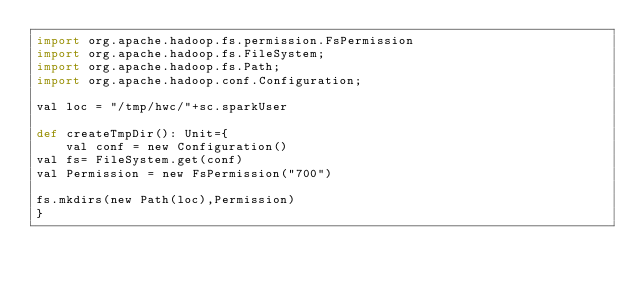Convert code to text. <code><loc_0><loc_0><loc_500><loc_500><_Python_>import org.apache.hadoop.fs.permission.FsPermission
import org.apache.hadoop.fs.FileSystem;
import org.apache.hadoop.fs.Path;
import org.apache.hadoop.conf.Configuration;

val loc = "/tmp/hwc/"+sc.sparkUser

def createTmpDir(): Unit={
    val conf = new Configuration()
val fs= FileSystem.get(conf)
val Permission = new FsPermission("700")

fs.mkdirs(new Path(loc),Permission)
}
</code> 